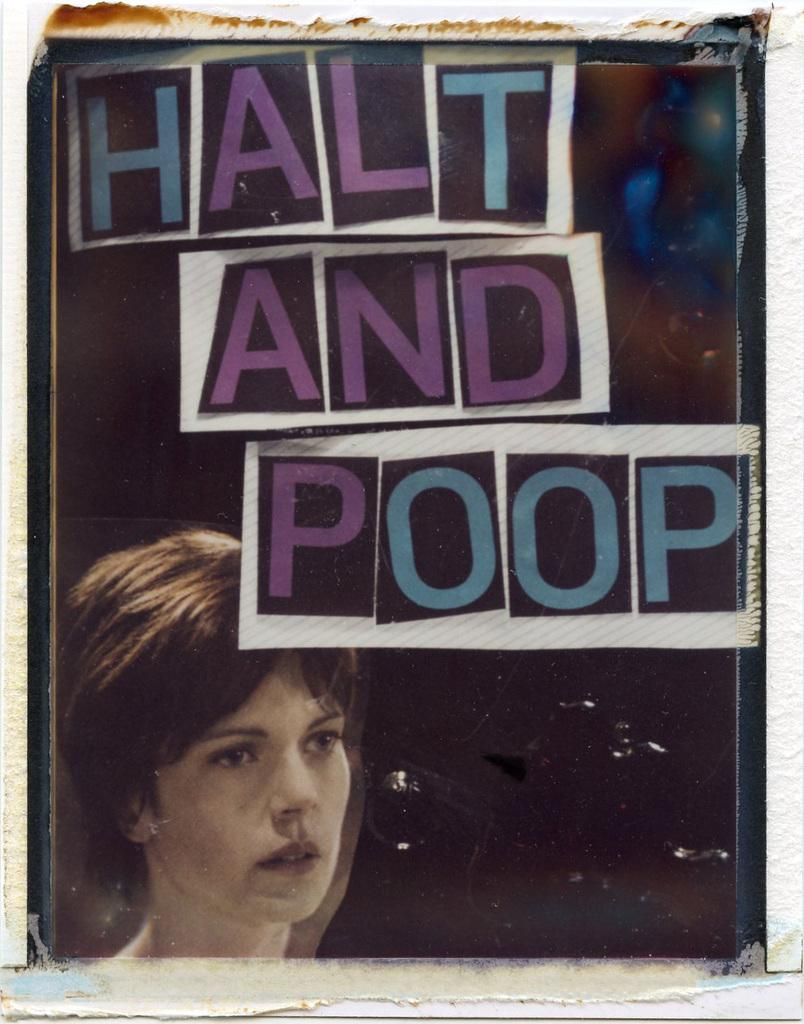What is featured on the poster in the image? There is a poster in the image, and it contains a picture of a woman. What else is included on the poster besides the image? The poster includes text. What type of health advice is the woman on the poster providing? There is no indication in the image that the woman on the poster is providing health advice, as the poster only contains a picture of a woman and text. What type of belief system does the woman on the poster represent? There is no indication in the image that the woman on the poster represents any specific belief system, as the poster only contains a picture of a woman and text. 